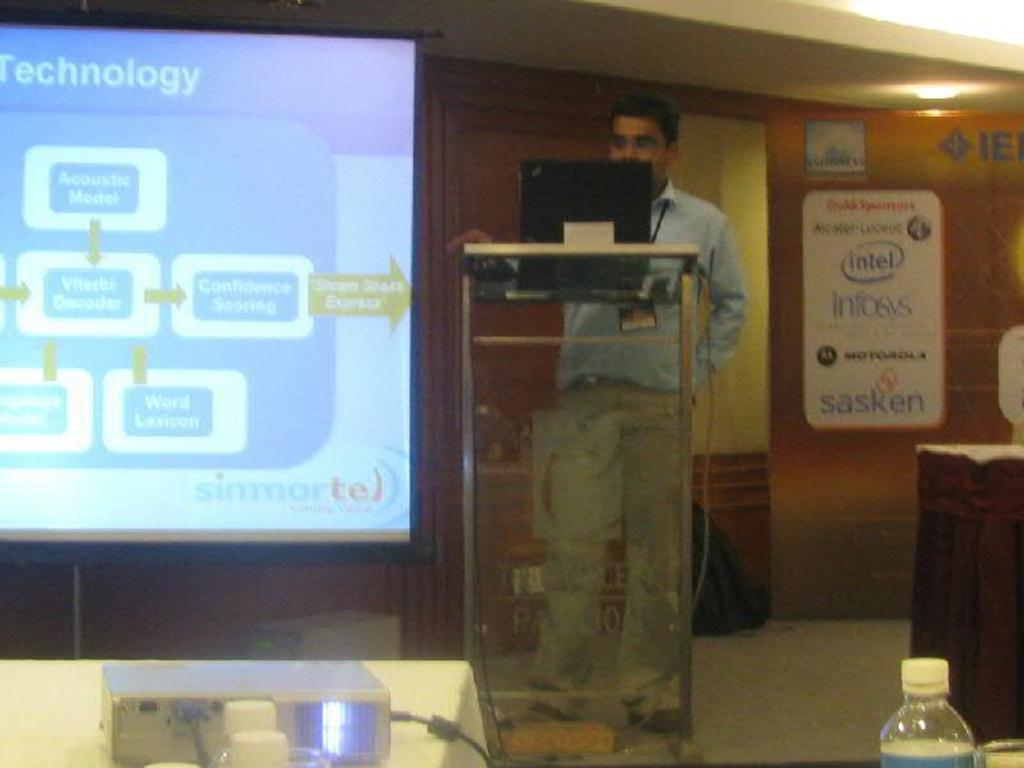Provide a one-sentence caption for the provided image. A man standing in the front of the room giving a presentation on technology. 